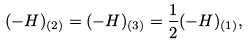Convert formula to latex. <formula><loc_0><loc_0><loc_500><loc_500>( - H ) _ { ( 2 ) } = ( - H ) _ { ( 3 ) } = \frac { 1 } { 2 } ( - H ) _ { ( 1 ) } ,</formula> 